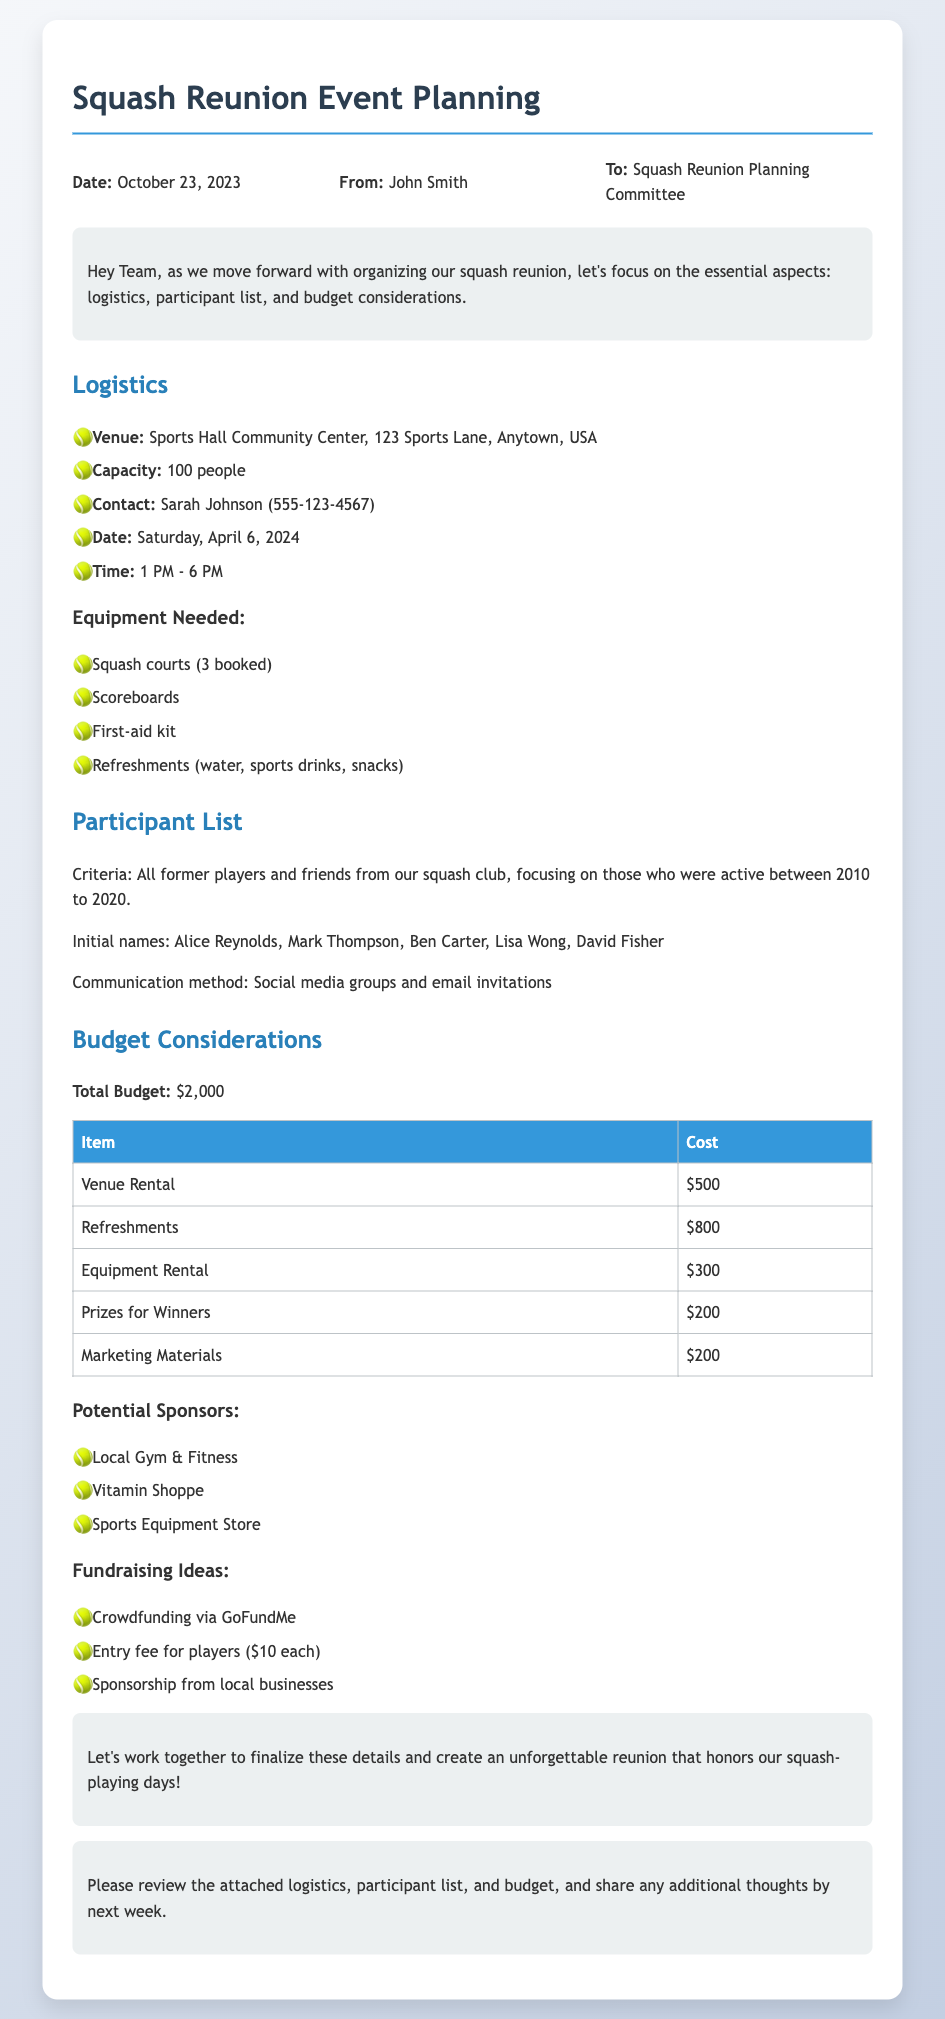What is the date of the squash reunion? The date is specified in the document under the logistics section.
Answer: Saturday, April 6, 2024 Who is the contact person for the venue? The contact person is mentioned in the logistics section of the document.
Answer: Sarah Johnson What is the total budget for the event? The total budget is clearly stated in the budget considerations section of the memo.
Answer: $2,000 How many people can the venue accommodate? The venue's capacity is provided in the logistics section of the document.
Answer: 100 people What are the initial names on the participant list? The document lists the initial participants under the participant list section.
Answer: Alice Reynolds, Mark Thompson, Ben Carter, Lisa Wong, David Fisher What type of method is suggested for communication? The communication method is indicated in the participant list section of the document.
Answer: Social media groups and email invitations How many squash courts are booked for the event? The number of booked squash courts is specified in the equipment needed list of the logistics section.
Answer: 3 What fundraising idea includes an entry fee? The fundraising ideas section includes various methods, one of which specifies an entry fee.
Answer: Entry fee for players ($10 each) What is the cost of refreshments? The cost of refreshments is detailed in the budget table of the document.
Answer: $800 